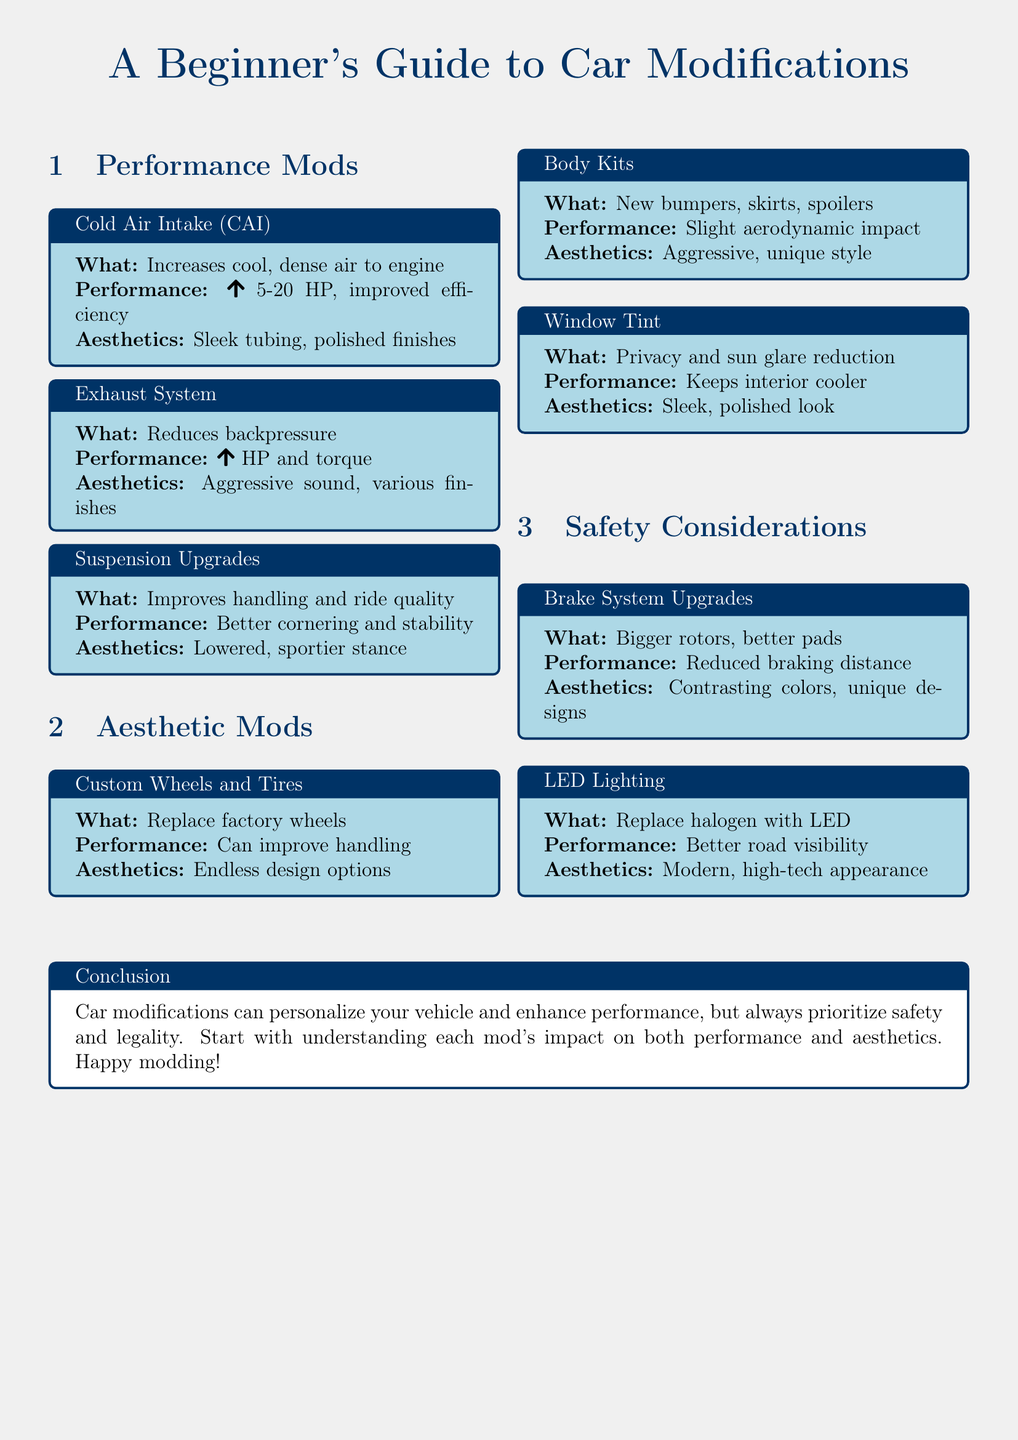What is a Cold Air Intake (CAI)? A Cold Air Intake (CAI) is a modification that increases cool, dense air to the engine.
Answer: Increases cool, dense air to engine How many horsepower can performance mods increase? Performance mods such as Cold Air Intake can increase horsepower by a range of 5 to 20 HP.
Answer: 5-20 HP What is the impact of Suspension Upgrades on handling? Suspension Upgrades improve handling and ride quality, leading to better cornering and stability.
Answer: Better handling and ride quality What type of aesthetic mod involves new bumpers and spoilers? Body Kits are modifications that include new bumpers, skirts, and spoilers.
Answer: Body Kits What aesthetic benefit does Window Tint provide? Window Tint provides a sleek, polished look and reduces sun glare.
Answer: Sleek, polished look What must you prioritize when modifying a vehicle? It's important to prioritize safety and legality when modifying a vehicle.
Answer: Safety and legality How do LED Lighting modifications impact road visibility? LED Lighting replaces halogen lights to provide better road visibility.
Answer: Better road visibility What is the aesthetic effect of Brake System Upgrades? Brake System Upgrades can have unique designs and contrasting colors.
Answer: Contrasting colors, unique designs 